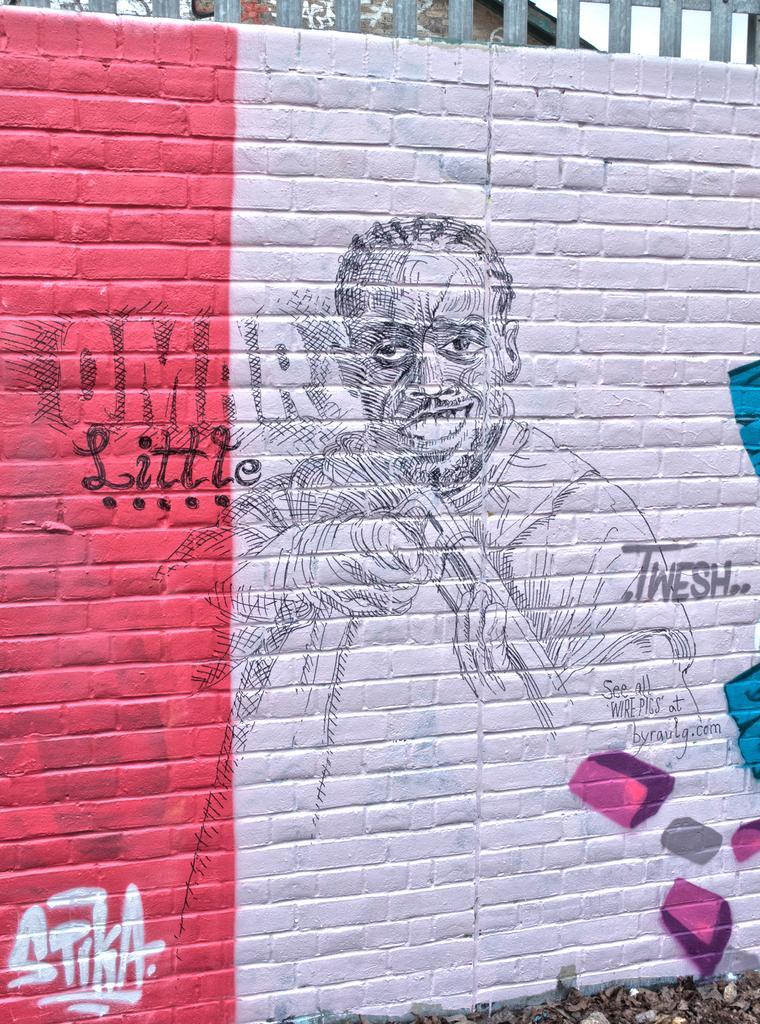Describe this image in one or two sentences. In this image we can see there is a wall and it is painted with a picture and some text written in it. And at the back there is a fence. 